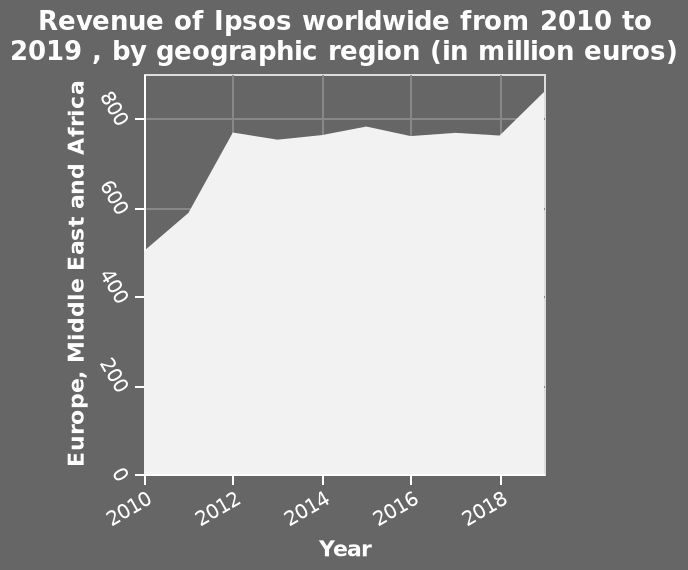<image>
What region does the y-axis measure?  The y-axis measures Europe, Middle East, and Africa. What was the ending income of Ipsos in 2018? The ending income of Ipsos in 2018 was 850 million. What is the range of the y-axis on the area diagram?  The range of the y-axis on the area diagram is from 0 to 800. Did the income fluctuate during the period? Yes, the income fluctuated during the period. 